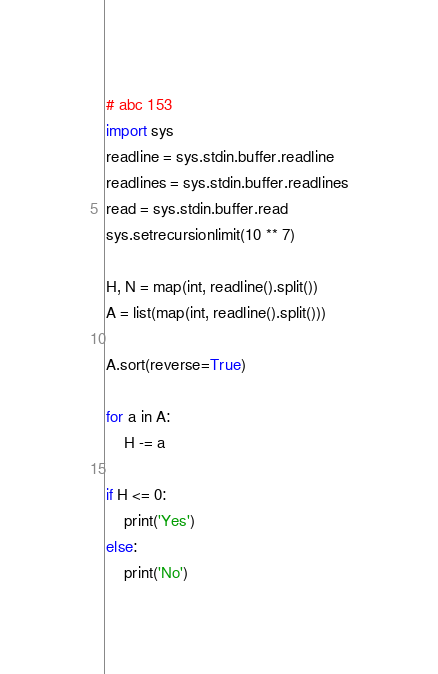<code> <loc_0><loc_0><loc_500><loc_500><_Python_># abc 153
import sys
readline = sys.stdin.buffer.readline
readlines = sys.stdin.buffer.readlines
read = sys.stdin.buffer.read
sys.setrecursionlimit(10 ** 7)

H, N = map(int, readline().split())
A = list(map(int, readline().split()))

A.sort(reverse=True)

for a in A:
    H -= a

if H <= 0:
    print('Yes')
else:
    print('No')
</code> 